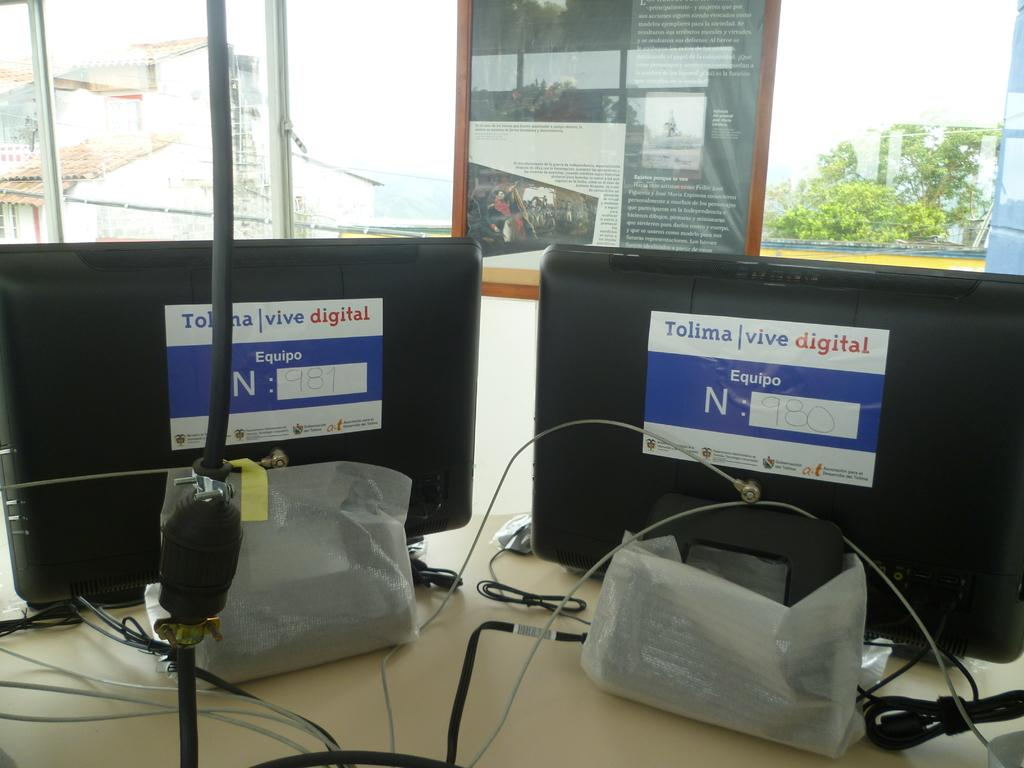<image>
Describe the image concisely. Two computers with Tolima Vive digital stickers on them. 